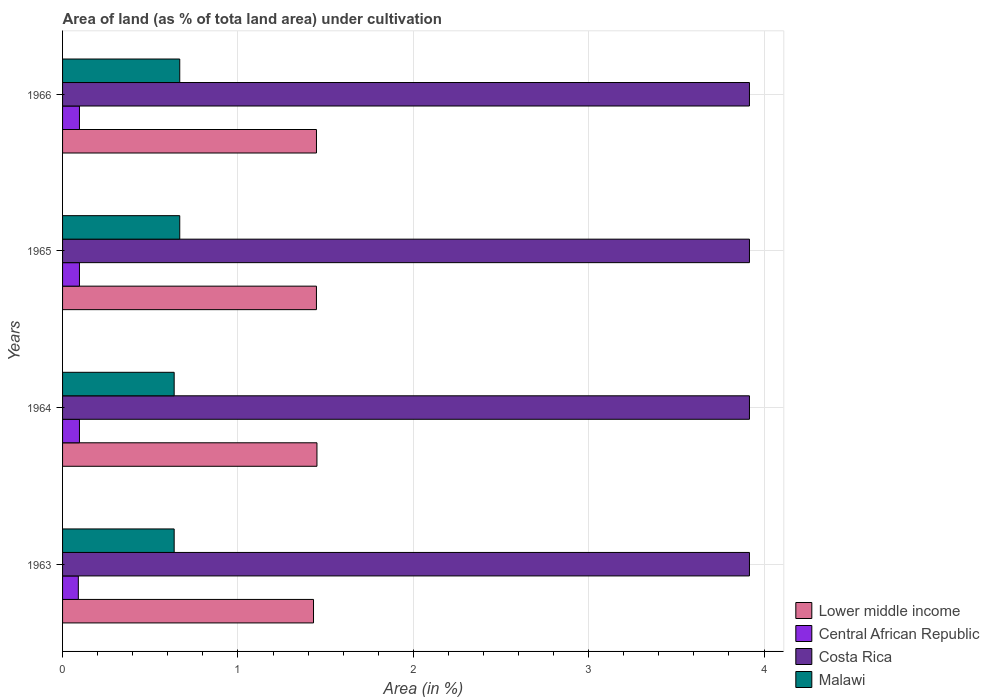Are the number of bars per tick equal to the number of legend labels?
Provide a short and direct response. Yes. Are the number of bars on each tick of the Y-axis equal?
Offer a terse response. Yes. How many bars are there on the 4th tick from the bottom?
Your answer should be very brief. 4. In how many cases, is the number of bars for a given year not equal to the number of legend labels?
Give a very brief answer. 0. What is the percentage of land under cultivation in Central African Republic in 1966?
Keep it short and to the point. 0.1. Across all years, what is the maximum percentage of land under cultivation in Lower middle income?
Your answer should be very brief. 1.45. Across all years, what is the minimum percentage of land under cultivation in Lower middle income?
Your answer should be very brief. 1.43. In which year was the percentage of land under cultivation in Malawi minimum?
Provide a succinct answer. 1963. What is the total percentage of land under cultivation in Central African Republic in the graph?
Make the answer very short. 0.38. What is the difference between the percentage of land under cultivation in Central African Republic in 1965 and the percentage of land under cultivation in Costa Rica in 1963?
Keep it short and to the point. -3.82. What is the average percentage of land under cultivation in Central African Republic per year?
Give a very brief answer. 0.09. In the year 1963, what is the difference between the percentage of land under cultivation in Malawi and percentage of land under cultivation in Costa Rica?
Provide a short and direct response. -3.28. What is the ratio of the percentage of land under cultivation in Malawi in 1964 to that in 1966?
Offer a terse response. 0.95. What is the difference between the highest and the lowest percentage of land under cultivation in Lower middle income?
Provide a short and direct response. 0.02. Is the sum of the percentage of land under cultivation in Malawi in 1963 and 1966 greater than the maximum percentage of land under cultivation in Lower middle income across all years?
Make the answer very short. No. What does the 1st bar from the bottom in 1965 represents?
Your answer should be compact. Lower middle income. Is it the case that in every year, the sum of the percentage of land under cultivation in Malawi and percentage of land under cultivation in Central African Republic is greater than the percentage of land under cultivation in Lower middle income?
Give a very brief answer. No. Are all the bars in the graph horizontal?
Provide a succinct answer. Yes. How many years are there in the graph?
Provide a short and direct response. 4. Are the values on the major ticks of X-axis written in scientific E-notation?
Provide a succinct answer. No. Does the graph contain any zero values?
Offer a terse response. No. Where does the legend appear in the graph?
Your answer should be very brief. Bottom right. How many legend labels are there?
Ensure brevity in your answer.  4. How are the legend labels stacked?
Offer a very short reply. Vertical. What is the title of the graph?
Your answer should be very brief. Area of land (as % of tota land area) under cultivation. What is the label or title of the X-axis?
Your response must be concise. Area (in %). What is the label or title of the Y-axis?
Your answer should be very brief. Years. What is the Area (in %) of Lower middle income in 1963?
Ensure brevity in your answer.  1.43. What is the Area (in %) of Central African Republic in 1963?
Your response must be concise. 0.09. What is the Area (in %) in Costa Rica in 1963?
Offer a terse response. 3.92. What is the Area (in %) of Malawi in 1963?
Give a very brief answer. 0.64. What is the Area (in %) in Lower middle income in 1964?
Make the answer very short. 1.45. What is the Area (in %) in Central African Republic in 1964?
Make the answer very short. 0.1. What is the Area (in %) in Costa Rica in 1964?
Provide a short and direct response. 3.92. What is the Area (in %) in Malawi in 1964?
Your answer should be compact. 0.64. What is the Area (in %) in Lower middle income in 1965?
Keep it short and to the point. 1.45. What is the Area (in %) in Central African Republic in 1965?
Offer a terse response. 0.1. What is the Area (in %) in Costa Rica in 1965?
Your answer should be compact. 3.92. What is the Area (in %) in Malawi in 1965?
Provide a short and direct response. 0.67. What is the Area (in %) in Lower middle income in 1966?
Your answer should be compact. 1.45. What is the Area (in %) in Central African Republic in 1966?
Your response must be concise. 0.1. What is the Area (in %) of Costa Rica in 1966?
Make the answer very short. 3.92. What is the Area (in %) of Malawi in 1966?
Your answer should be compact. 0.67. Across all years, what is the maximum Area (in %) in Lower middle income?
Offer a very short reply. 1.45. Across all years, what is the maximum Area (in %) of Central African Republic?
Your response must be concise. 0.1. Across all years, what is the maximum Area (in %) in Costa Rica?
Your response must be concise. 3.92. Across all years, what is the maximum Area (in %) of Malawi?
Ensure brevity in your answer.  0.67. Across all years, what is the minimum Area (in %) in Lower middle income?
Make the answer very short. 1.43. Across all years, what is the minimum Area (in %) of Central African Republic?
Offer a terse response. 0.09. Across all years, what is the minimum Area (in %) in Costa Rica?
Your answer should be compact. 3.92. Across all years, what is the minimum Area (in %) of Malawi?
Ensure brevity in your answer.  0.64. What is the total Area (in %) in Lower middle income in the graph?
Your answer should be very brief. 5.78. What is the total Area (in %) of Central African Republic in the graph?
Offer a terse response. 0.38. What is the total Area (in %) in Costa Rica in the graph?
Keep it short and to the point. 15.67. What is the total Area (in %) of Malawi in the graph?
Give a very brief answer. 2.61. What is the difference between the Area (in %) of Lower middle income in 1963 and that in 1964?
Your response must be concise. -0.02. What is the difference between the Area (in %) in Central African Republic in 1963 and that in 1964?
Give a very brief answer. -0.01. What is the difference between the Area (in %) of Costa Rica in 1963 and that in 1964?
Keep it short and to the point. 0. What is the difference between the Area (in %) of Malawi in 1963 and that in 1964?
Make the answer very short. 0. What is the difference between the Area (in %) in Lower middle income in 1963 and that in 1965?
Give a very brief answer. -0.02. What is the difference between the Area (in %) in Central African Republic in 1963 and that in 1965?
Offer a very short reply. -0.01. What is the difference between the Area (in %) of Malawi in 1963 and that in 1965?
Give a very brief answer. -0.03. What is the difference between the Area (in %) of Lower middle income in 1963 and that in 1966?
Give a very brief answer. -0.02. What is the difference between the Area (in %) of Central African Republic in 1963 and that in 1966?
Keep it short and to the point. -0.01. What is the difference between the Area (in %) of Costa Rica in 1963 and that in 1966?
Keep it short and to the point. 0. What is the difference between the Area (in %) of Malawi in 1963 and that in 1966?
Offer a terse response. -0.03. What is the difference between the Area (in %) of Lower middle income in 1964 and that in 1965?
Ensure brevity in your answer.  0. What is the difference between the Area (in %) in Central African Republic in 1964 and that in 1965?
Keep it short and to the point. 0. What is the difference between the Area (in %) of Malawi in 1964 and that in 1965?
Provide a short and direct response. -0.03. What is the difference between the Area (in %) in Lower middle income in 1964 and that in 1966?
Give a very brief answer. 0. What is the difference between the Area (in %) in Costa Rica in 1964 and that in 1966?
Make the answer very short. 0. What is the difference between the Area (in %) in Malawi in 1964 and that in 1966?
Keep it short and to the point. -0.03. What is the difference between the Area (in %) in Lower middle income in 1965 and that in 1966?
Give a very brief answer. -0. What is the difference between the Area (in %) of Central African Republic in 1965 and that in 1966?
Your answer should be compact. 0. What is the difference between the Area (in %) in Malawi in 1965 and that in 1966?
Your answer should be compact. 0. What is the difference between the Area (in %) of Lower middle income in 1963 and the Area (in %) of Central African Republic in 1964?
Make the answer very short. 1.33. What is the difference between the Area (in %) of Lower middle income in 1963 and the Area (in %) of Costa Rica in 1964?
Offer a very short reply. -2.49. What is the difference between the Area (in %) of Lower middle income in 1963 and the Area (in %) of Malawi in 1964?
Offer a very short reply. 0.79. What is the difference between the Area (in %) in Central African Republic in 1963 and the Area (in %) in Costa Rica in 1964?
Ensure brevity in your answer.  -3.83. What is the difference between the Area (in %) in Central African Republic in 1963 and the Area (in %) in Malawi in 1964?
Provide a short and direct response. -0.55. What is the difference between the Area (in %) in Costa Rica in 1963 and the Area (in %) in Malawi in 1964?
Make the answer very short. 3.28. What is the difference between the Area (in %) in Lower middle income in 1963 and the Area (in %) in Central African Republic in 1965?
Your answer should be very brief. 1.33. What is the difference between the Area (in %) in Lower middle income in 1963 and the Area (in %) in Costa Rica in 1965?
Make the answer very short. -2.49. What is the difference between the Area (in %) in Lower middle income in 1963 and the Area (in %) in Malawi in 1965?
Offer a terse response. 0.76. What is the difference between the Area (in %) of Central African Republic in 1963 and the Area (in %) of Costa Rica in 1965?
Your response must be concise. -3.83. What is the difference between the Area (in %) of Central African Republic in 1963 and the Area (in %) of Malawi in 1965?
Give a very brief answer. -0.58. What is the difference between the Area (in %) of Costa Rica in 1963 and the Area (in %) of Malawi in 1965?
Provide a succinct answer. 3.25. What is the difference between the Area (in %) in Lower middle income in 1963 and the Area (in %) in Central African Republic in 1966?
Make the answer very short. 1.33. What is the difference between the Area (in %) in Lower middle income in 1963 and the Area (in %) in Costa Rica in 1966?
Your response must be concise. -2.49. What is the difference between the Area (in %) in Lower middle income in 1963 and the Area (in %) in Malawi in 1966?
Make the answer very short. 0.76. What is the difference between the Area (in %) of Central African Republic in 1963 and the Area (in %) of Costa Rica in 1966?
Ensure brevity in your answer.  -3.83. What is the difference between the Area (in %) of Central African Republic in 1963 and the Area (in %) of Malawi in 1966?
Your answer should be compact. -0.58. What is the difference between the Area (in %) in Costa Rica in 1963 and the Area (in %) in Malawi in 1966?
Provide a succinct answer. 3.25. What is the difference between the Area (in %) in Lower middle income in 1964 and the Area (in %) in Central African Republic in 1965?
Your answer should be very brief. 1.35. What is the difference between the Area (in %) in Lower middle income in 1964 and the Area (in %) in Costa Rica in 1965?
Your response must be concise. -2.47. What is the difference between the Area (in %) in Lower middle income in 1964 and the Area (in %) in Malawi in 1965?
Provide a succinct answer. 0.78. What is the difference between the Area (in %) of Central African Republic in 1964 and the Area (in %) of Costa Rica in 1965?
Your response must be concise. -3.82. What is the difference between the Area (in %) of Central African Republic in 1964 and the Area (in %) of Malawi in 1965?
Your response must be concise. -0.57. What is the difference between the Area (in %) in Costa Rica in 1964 and the Area (in %) in Malawi in 1965?
Provide a short and direct response. 3.25. What is the difference between the Area (in %) of Lower middle income in 1964 and the Area (in %) of Central African Republic in 1966?
Provide a short and direct response. 1.35. What is the difference between the Area (in %) of Lower middle income in 1964 and the Area (in %) of Costa Rica in 1966?
Give a very brief answer. -2.47. What is the difference between the Area (in %) in Lower middle income in 1964 and the Area (in %) in Malawi in 1966?
Provide a succinct answer. 0.78. What is the difference between the Area (in %) of Central African Republic in 1964 and the Area (in %) of Costa Rica in 1966?
Ensure brevity in your answer.  -3.82. What is the difference between the Area (in %) in Central African Republic in 1964 and the Area (in %) in Malawi in 1966?
Give a very brief answer. -0.57. What is the difference between the Area (in %) of Costa Rica in 1964 and the Area (in %) of Malawi in 1966?
Give a very brief answer. 3.25. What is the difference between the Area (in %) of Lower middle income in 1965 and the Area (in %) of Central African Republic in 1966?
Keep it short and to the point. 1.35. What is the difference between the Area (in %) in Lower middle income in 1965 and the Area (in %) in Costa Rica in 1966?
Give a very brief answer. -2.47. What is the difference between the Area (in %) of Lower middle income in 1965 and the Area (in %) of Malawi in 1966?
Give a very brief answer. 0.78. What is the difference between the Area (in %) in Central African Republic in 1965 and the Area (in %) in Costa Rica in 1966?
Provide a succinct answer. -3.82. What is the difference between the Area (in %) of Central African Republic in 1965 and the Area (in %) of Malawi in 1966?
Your answer should be very brief. -0.57. What is the difference between the Area (in %) in Costa Rica in 1965 and the Area (in %) in Malawi in 1966?
Keep it short and to the point. 3.25. What is the average Area (in %) of Lower middle income per year?
Ensure brevity in your answer.  1.44. What is the average Area (in %) of Central African Republic per year?
Offer a terse response. 0.09. What is the average Area (in %) in Costa Rica per year?
Give a very brief answer. 3.92. What is the average Area (in %) in Malawi per year?
Keep it short and to the point. 0.65. In the year 1963, what is the difference between the Area (in %) in Lower middle income and Area (in %) in Central African Republic?
Your response must be concise. 1.34. In the year 1963, what is the difference between the Area (in %) in Lower middle income and Area (in %) in Costa Rica?
Keep it short and to the point. -2.49. In the year 1963, what is the difference between the Area (in %) of Lower middle income and Area (in %) of Malawi?
Your response must be concise. 0.79. In the year 1963, what is the difference between the Area (in %) of Central African Republic and Area (in %) of Costa Rica?
Make the answer very short. -3.83. In the year 1963, what is the difference between the Area (in %) of Central African Republic and Area (in %) of Malawi?
Give a very brief answer. -0.55. In the year 1963, what is the difference between the Area (in %) in Costa Rica and Area (in %) in Malawi?
Your answer should be compact. 3.28. In the year 1964, what is the difference between the Area (in %) of Lower middle income and Area (in %) of Central African Republic?
Keep it short and to the point. 1.35. In the year 1964, what is the difference between the Area (in %) of Lower middle income and Area (in %) of Costa Rica?
Your response must be concise. -2.47. In the year 1964, what is the difference between the Area (in %) in Lower middle income and Area (in %) in Malawi?
Your response must be concise. 0.81. In the year 1964, what is the difference between the Area (in %) in Central African Republic and Area (in %) in Costa Rica?
Make the answer very short. -3.82. In the year 1964, what is the difference between the Area (in %) in Central African Republic and Area (in %) in Malawi?
Your answer should be very brief. -0.54. In the year 1964, what is the difference between the Area (in %) in Costa Rica and Area (in %) in Malawi?
Offer a very short reply. 3.28. In the year 1965, what is the difference between the Area (in %) in Lower middle income and Area (in %) in Central African Republic?
Provide a short and direct response. 1.35. In the year 1965, what is the difference between the Area (in %) of Lower middle income and Area (in %) of Costa Rica?
Your answer should be compact. -2.47. In the year 1965, what is the difference between the Area (in %) of Lower middle income and Area (in %) of Malawi?
Your response must be concise. 0.78. In the year 1965, what is the difference between the Area (in %) of Central African Republic and Area (in %) of Costa Rica?
Offer a terse response. -3.82. In the year 1965, what is the difference between the Area (in %) in Central African Republic and Area (in %) in Malawi?
Provide a succinct answer. -0.57. In the year 1965, what is the difference between the Area (in %) in Costa Rica and Area (in %) in Malawi?
Ensure brevity in your answer.  3.25. In the year 1966, what is the difference between the Area (in %) in Lower middle income and Area (in %) in Central African Republic?
Ensure brevity in your answer.  1.35. In the year 1966, what is the difference between the Area (in %) of Lower middle income and Area (in %) of Costa Rica?
Provide a short and direct response. -2.47. In the year 1966, what is the difference between the Area (in %) of Lower middle income and Area (in %) of Malawi?
Keep it short and to the point. 0.78. In the year 1966, what is the difference between the Area (in %) in Central African Republic and Area (in %) in Costa Rica?
Make the answer very short. -3.82. In the year 1966, what is the difference between the Area (in %) in Central African Republic and Area (in %) in Malawi?
Offer a terse response. -0.57. In the year 1966, what is the difference between the Area (in %) in Costa Rica and Area (in %) in Malawi?
Make the answer very short. 3.25. What is the ratio of the Area (in %) of Lower middle income in 1963 to that in 1964?
Make the answer very short. 0.99. What is the ratio of the Area (in %) of Central African Republic in 1963 to that in 1964?
Provide a short and direct response. 0.93. What is the ratio of the Area (in %) in Costa Rica in 1963 to that in 1964?
Provide a short and direct response. 1. What is the ratio of the Area (in %) in Malawi in 1963 to that in 1964?
Make the answer very short. 1. What is the ratio of the Area (in %) in Malawi in 1963 to that in 1965?
Offer a very short reply. 0.95. What is the ratio of the Area (in %) in Lower middle income in 1963 to that in 1966?
Offer a very short reply. 0.99. What is the ratio of the Area (in %) in Central African Republic in 1963 to that in 1966?
Your answer should be very brief. 0.93. What is the ratio of the Area (in %) of Costa Rica in 1964 to that in 1966?
Your answer should be compact. 1. What is the ratio of the Area (in %) in Lower middle income in 1965 to that in 1966?
Provide a succinct answer. 1. What is the ratio of the Area (in %) in Central African Republic in 1965 to that in 1966?
Your answer should be compact. 1. What is the ratio of the Area (in %) of Malawi in 1965 to that in 1966?
Offer a very short reply. 1. What is the difference between the highest and the second highest Area (in %) in Lower middle income?
Your answer should be compact. 0. What is the difference between the highest and the second highest Area (in %) of Central African Republic?
Provide a succinct answer. 0. What is the difference between the highest and the second highest Area (in %) in Costa Rica?
Provide a short and direct response. 0. What is the difference between the highest and the lowest Area (in %) in Lower middle income?
Ensure brevity in your answer.  0.02. What is the difference between the highest and the lowest Area (in %) of Central African Republic?
Make the answer very short. 0.01. What is the difference between the highest and the lowest Area (in %) in Malawi?
Offer a very short reply. 0.03. 